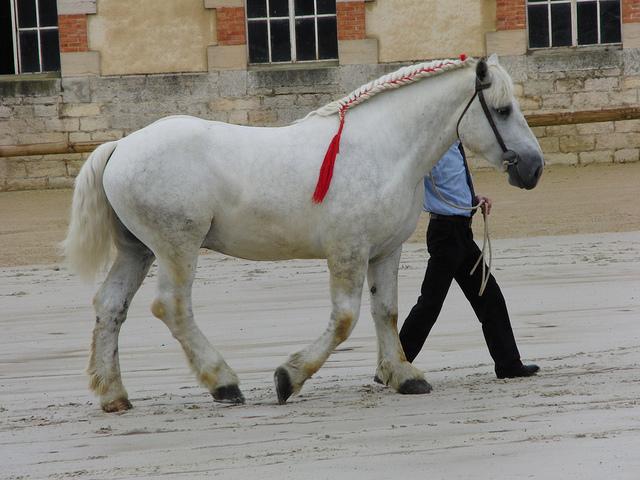Is the horse being cleaned?
Answer briefly. No. How many horses are walking on the road?
Concise answer only. 1. What animal is pictured?
Give a very brief answer. Horse. Is this photo colored?
Write a very short answer. Yes. Did someone lose the horse?
Concise answer only. No. What color is the horse?
Be succinct. White. What is hanging from the man's neck?
Concise answer only. Tie. Is the horse walking?
Write a very short answer. Yes. Is anyone riding the horse?
Keep it brief. No. What color is the sash around the gray horse?
Be succinct. Red. Is there a saddle on the horse?
Short answer required. No. What does the horse have on its mane?
Be succinct. Ribbon. 